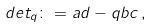<formula> <loc_0><loc_0><loc_500><loc_500>d e t _ { q } \colon = a d - q b c \, ,</formula> 